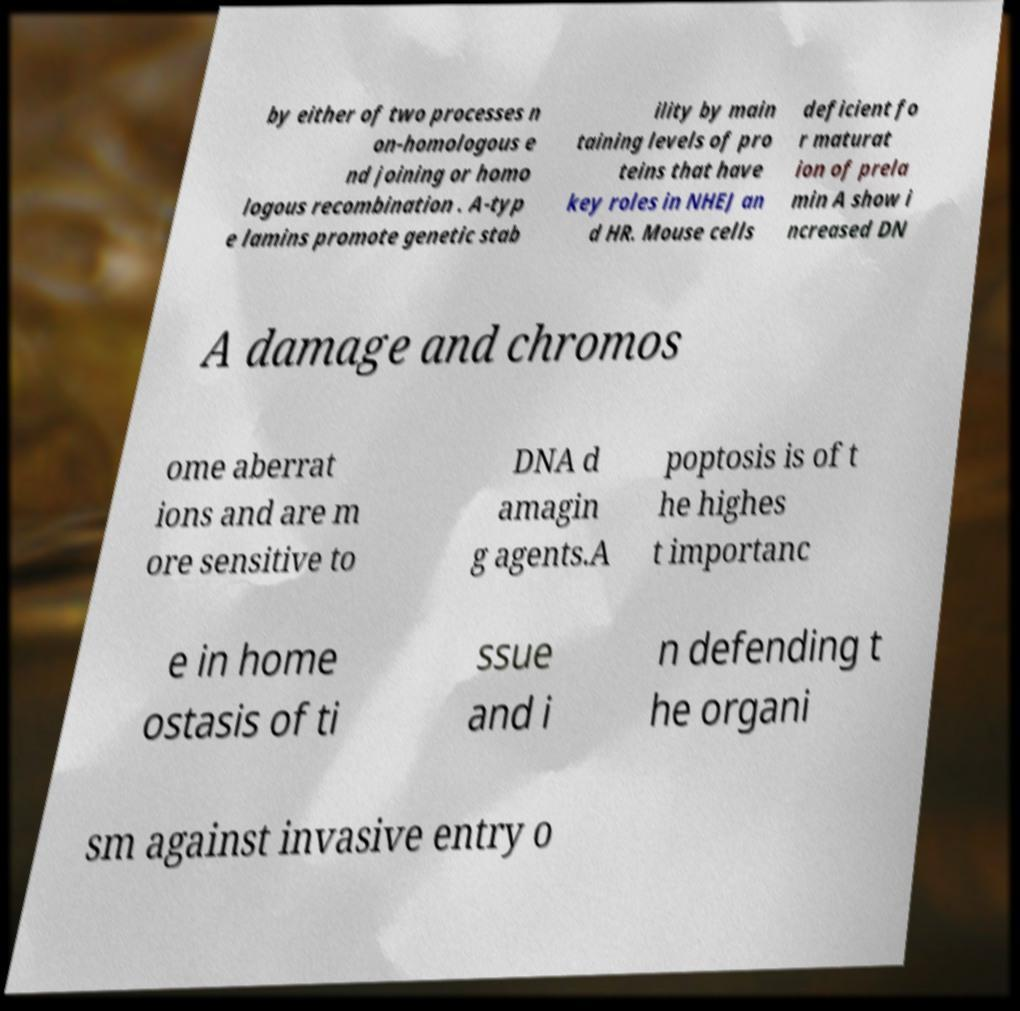I need the written content from this picture converted into text. Can you do that? by either of two processes n on-homologous e nd joining or homo logous recombination . A-typ e lamins promote genetic stab ility by main taining levels of pro teins that have key roles in NHEJ an d HR. Mouse cells deficient fo r maturat ion of prela min A show i ncreased DN A damage and chromos ome aberrat ions and are m ore sensitive to DNA d amagin g agents.A poptosis is of t he highes t importanc e in home ostasis of ti ssue and i n defending t he organi sm against invasive entry o 